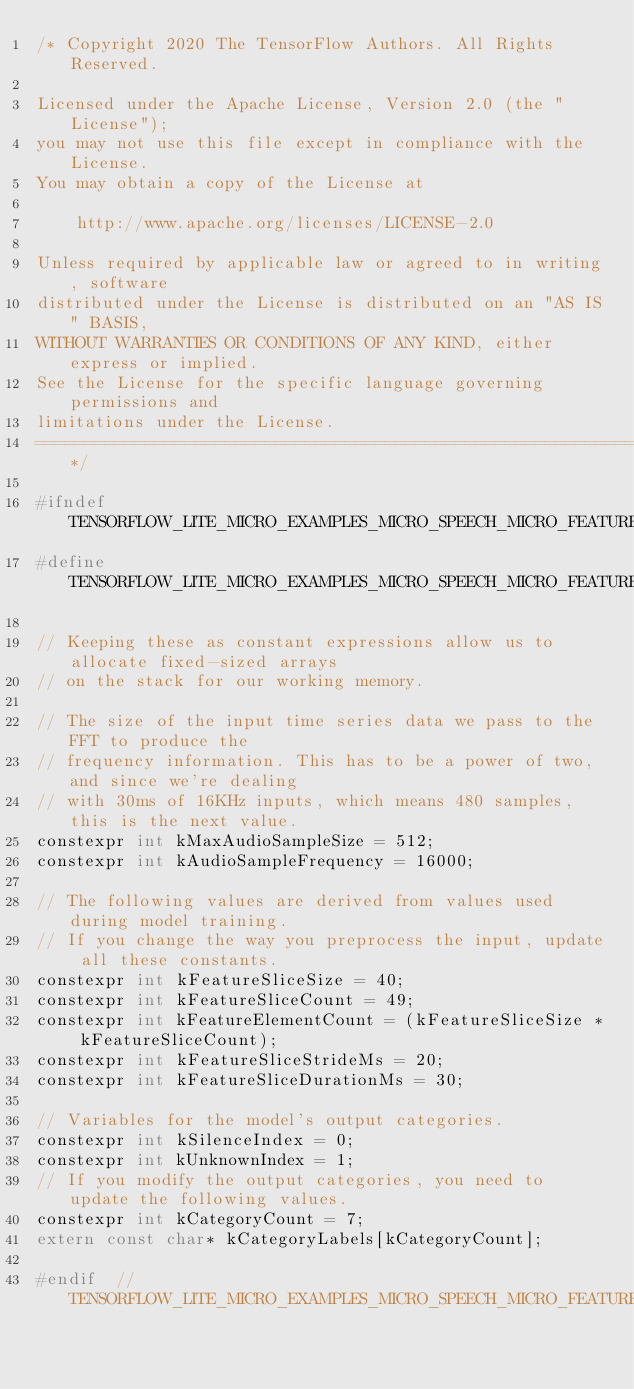<code> <loc_0><loc_0><loc_500><loc_500><_C_>/* Copyright 2020 The TensorFlow Authors. All Rights Reserved.

Licensed under the Apache License, Version 2.0 (the "License");
you may not use this file except in compliance with the License.
You may obtain a copy of the License at

    http://www.apache.org/licenses/LICENSE-2.0

Unless required by applicable law or agreed to in writing, software
distributed under the License is distributed on an "AS IS" BASIS,
WITHOUT WARRANTIES OR CONDITIONS OF ANY KIND, either express or implied.
See the License for the specific language governing permissions and
limitations under the License.
==============================================================================*/

#ifndef TENSORFLOW_LITE_MICRO_EXAMPLES_MICRO_SPEECH_MICRO_FEATURES_MICRO_MODEL_SETTINGS_H_
#define TENSORFLOW_LITE_MICRO_EXAMPLES_MICRO_SPEECH_MICRO_FEATURES_MICRO_MODEL_SETTINGS_H_

// Keeping these as constant expressions allow us to allocate fixed-sized arrays
// on the stack for our working memory.

// The size of the input time series data we pass to the FFT to produce the
// frequency information. This has to be a power of two, and since we're dealing
// with 30ms of 16KHz inputs, which means 480 samples, this is the next value.
constexpr int kMaxAudioSampleSize = 512;
constexpr int kAudioSampleFrequency = 16000;

// The following values are derived from values used during model training.
// If you change the way you preprocess the input, update all these constants.
constexpr int kFeatureSliceSize = 40;
constexpr int kFeatureSliceCount = 49;
constexpr int kFeatureElementCount = (kFeatureSliceSize * kFeatureSliceCount);
constexpr int kFeatureSliceStrideMs = 20;
constexpr int kFeatureSliceDurationMs = 30;

// Variables for the model's output categories.
constexpr int kSilenceIndex = 0;
constexpr int kUnknownIndex = 1;
// If you modify the output categories, you need to update the following values.
constexpr int kCategoryCount = 7;
extern const char* kCategoryLabels[kCategoryCount];

#endif  // TENSORFLOW_LITE_MICRO_EXAMPLES_MICRO_SPEECH_MICRO_FEATURES_MICRO_MODEL_SETTINGS_H_
</code> 